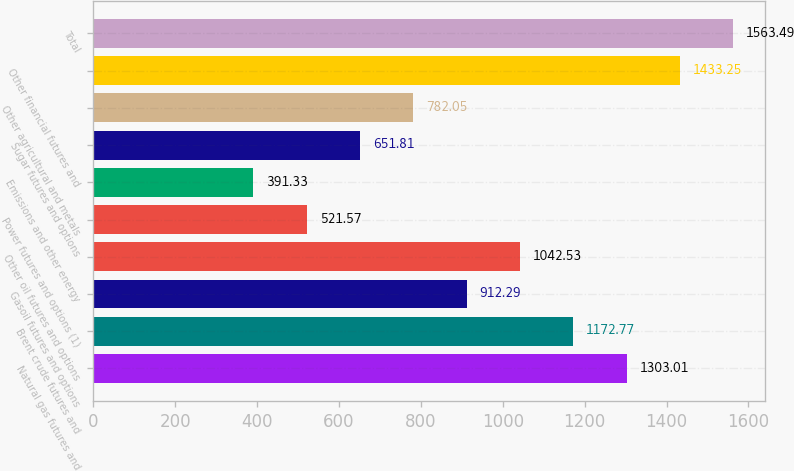<chart> <loc_0><loc_0><loc_500><loc_500><bar_chart><fcel>Natural gas futures and<fcel>Brent crude futures and<fcel>Gasoil futures and options<fcel>Other oil futures and options<fcel>Power futures and options (1)<fcel>Emissions and other energy<fcel>Sugar futures and options<fcel>Other agricultural and metals<fcel>Other financial futures and<fcel>Total<nl><fcel>1303.01<fcel>1172.77<fcel>912.29<fcel>1042.53<fcel>521.57<fcel>391.33<fcel>651.81<fcel>782.05<fcel>1433.25<fcel>1563.49<nl></chart> 